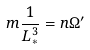Convert formula to latex. <formula><loc_0><loc_0><loc_500><loc_500>m \frac { 1 } { L _ { * } ^ { 3 } } = n \Omega ^ { \prime }</formula> 